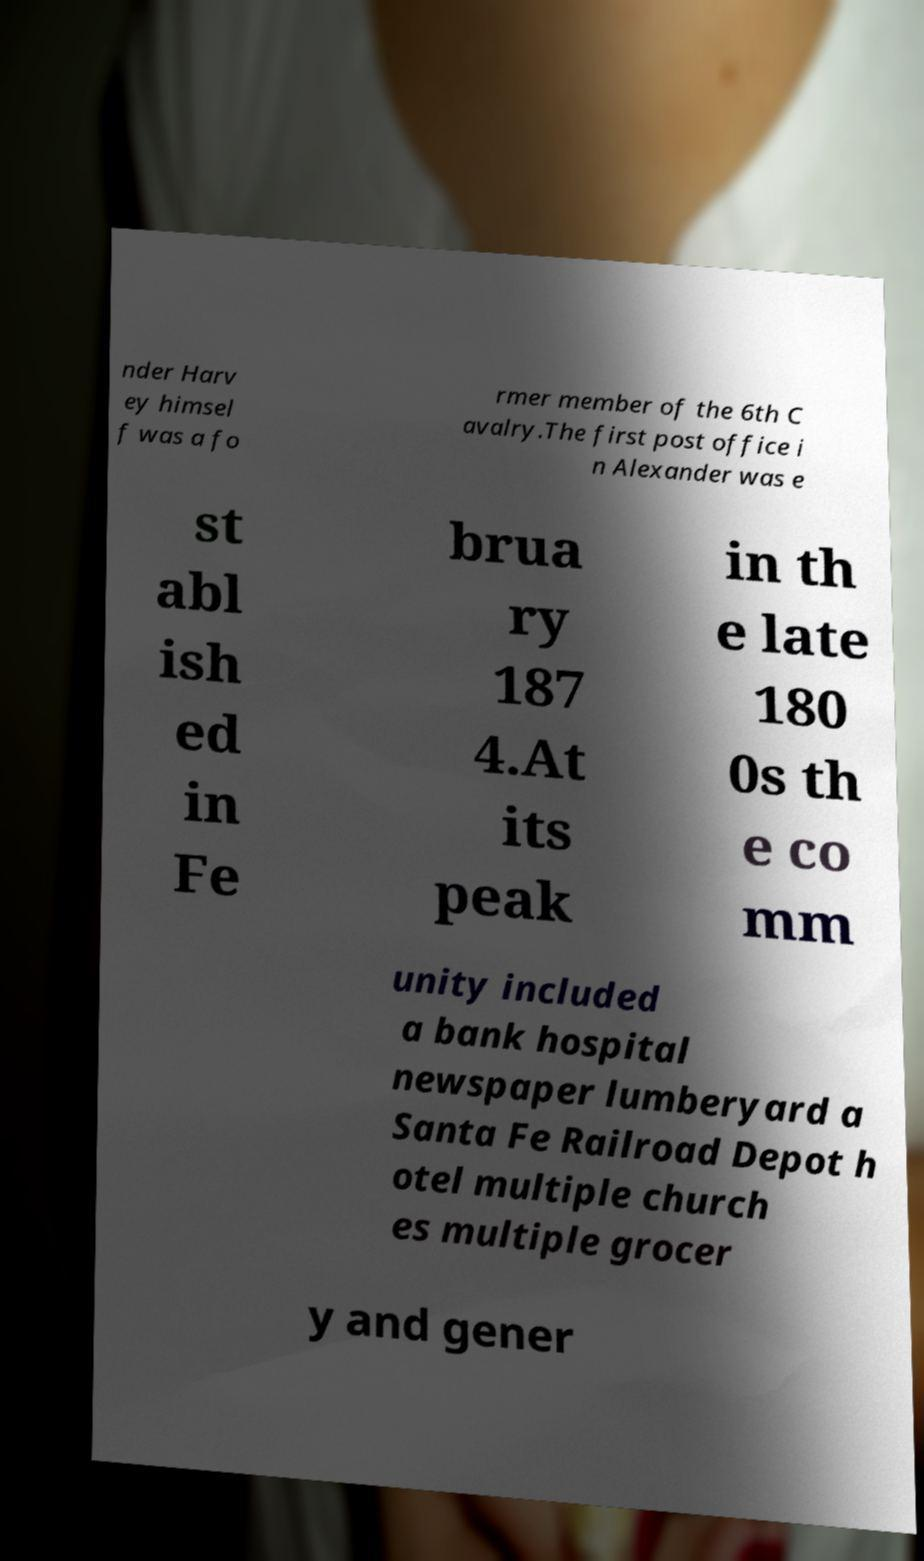Can you accurately transcribe the text from the provided image for me? nder Harv ey himsel f was a fo rmer member of the 6th C avalry.The first post office i n Alexander was e st abl ish ed in Fe brua ry 187 4.At its peak in th e late 180 0s th e co mm unity included a bank hospital newspaper lumberyard a Santa Fe Railroad Depot h otel multiple church es multiple grocer y and gener 